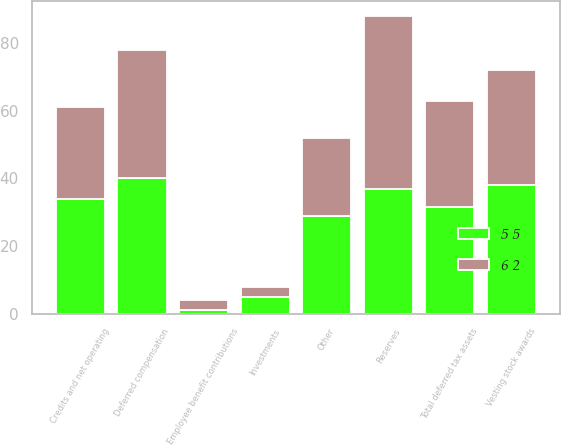Convert chart. <chart><loc_0><loc_0><loc_500><loc_500><stacked_bar_chart><ecel><fcel>Investments<fcel>Deferred compensation<fcel>Vesting stock awards<fcel>Credits and net operating<fcel>Employee benefit contributions<fcel>Reserves<fcel>Other<fcel>Total deferred tax assets<nl><fcel>6 2<fcel>3<fcel>38<fcel>34<fcel>27<fcel>3<fcel>51<fcel>23<fcel>31.5<nl><fcel>5 5<fcel>5<fcel>40<fcel>38<fcel>34<fcel>1<fcel>37<fcel>29<fcel>31.5<nl></chart> 